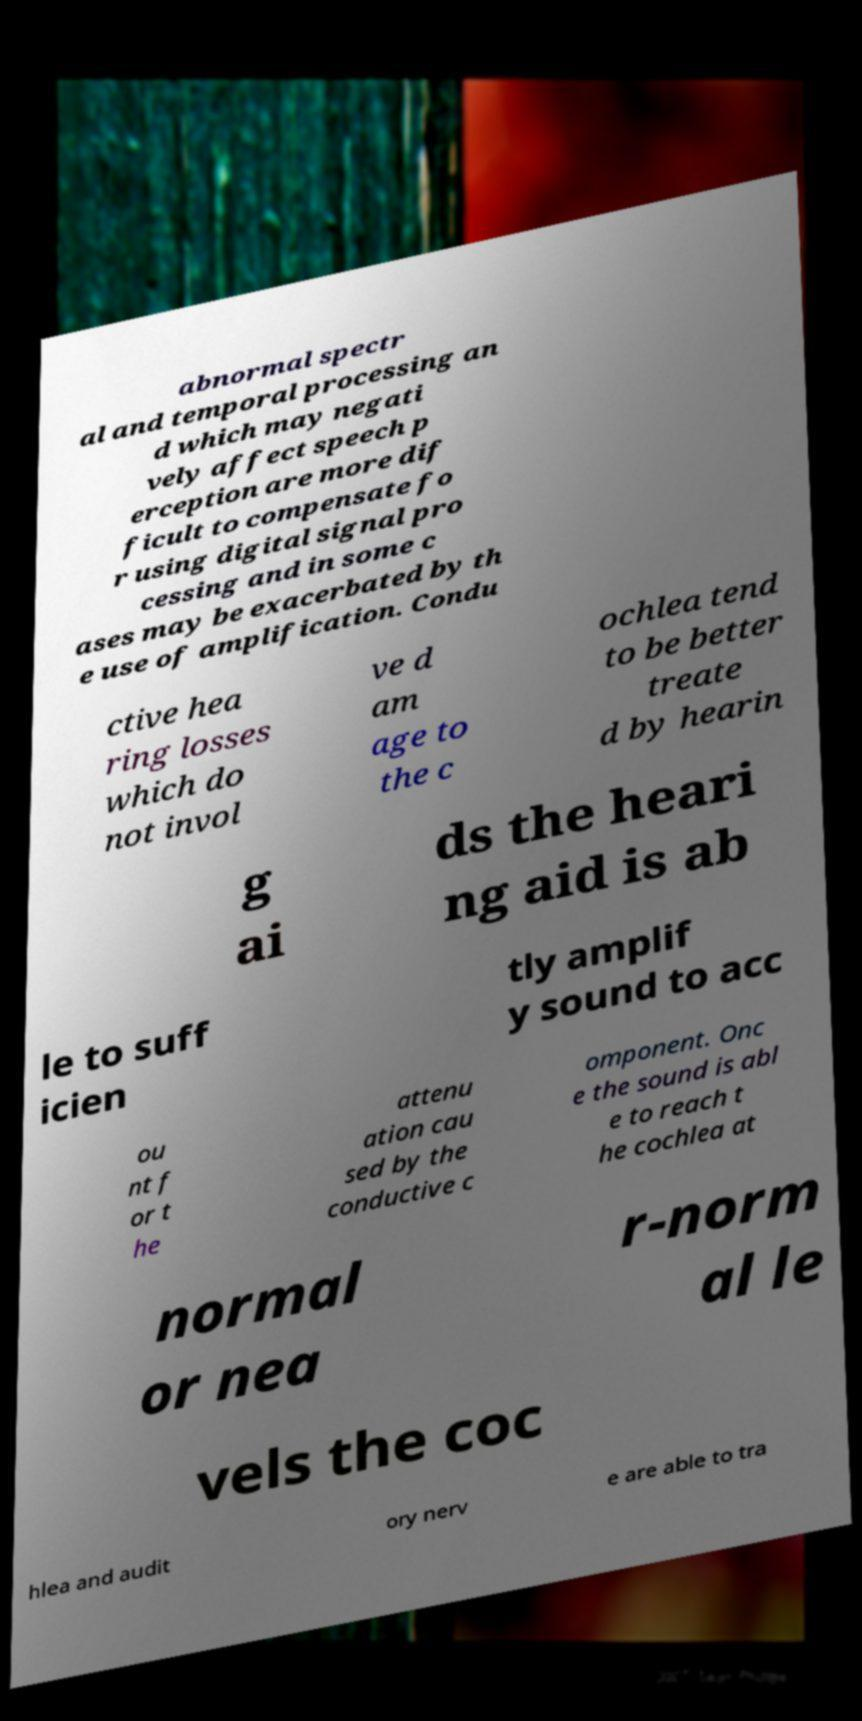I need the written content from this picture converted into text. Can you do that? abnormal spectr al and temporal processing an d which may negati vely affect speech p erception are more dif ficult to compensate fo r using digital signal pro cessing and in some c ases may be exacerbated by th e use of amplification. Condu ctive hea ring losses which do not invol ve d am age to the c ochlea tend to be better treate d by hearin g ai ds the heari ng aid is ab le to suff icien tly amplif y sound to acc ou nt f or t he attenu ation cau sed by the conductive c omponent. Onc e the sound is abl e to reach t he cochlea at normal or nea r-norm al le vels the coc hlea and audit ory nerv e are able to tra 